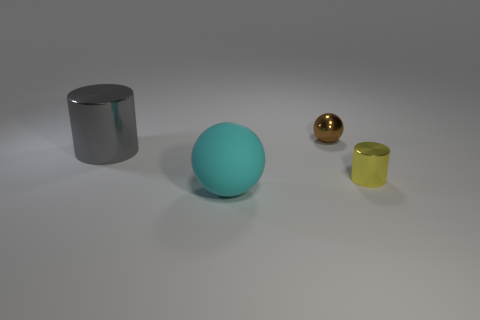Add 3 yellow metallic things. How many objects exist? 7 Add 1 big gray cylinders. How many big gray cylinders exist? 2 Subtract 0 gray spheres. How many objects are left? 4 Subtract all gray objects. Subtract all tiny metallic cylinders. How many objects are left? 2 Add 2 metallic things. How many metallic things are left? 5 